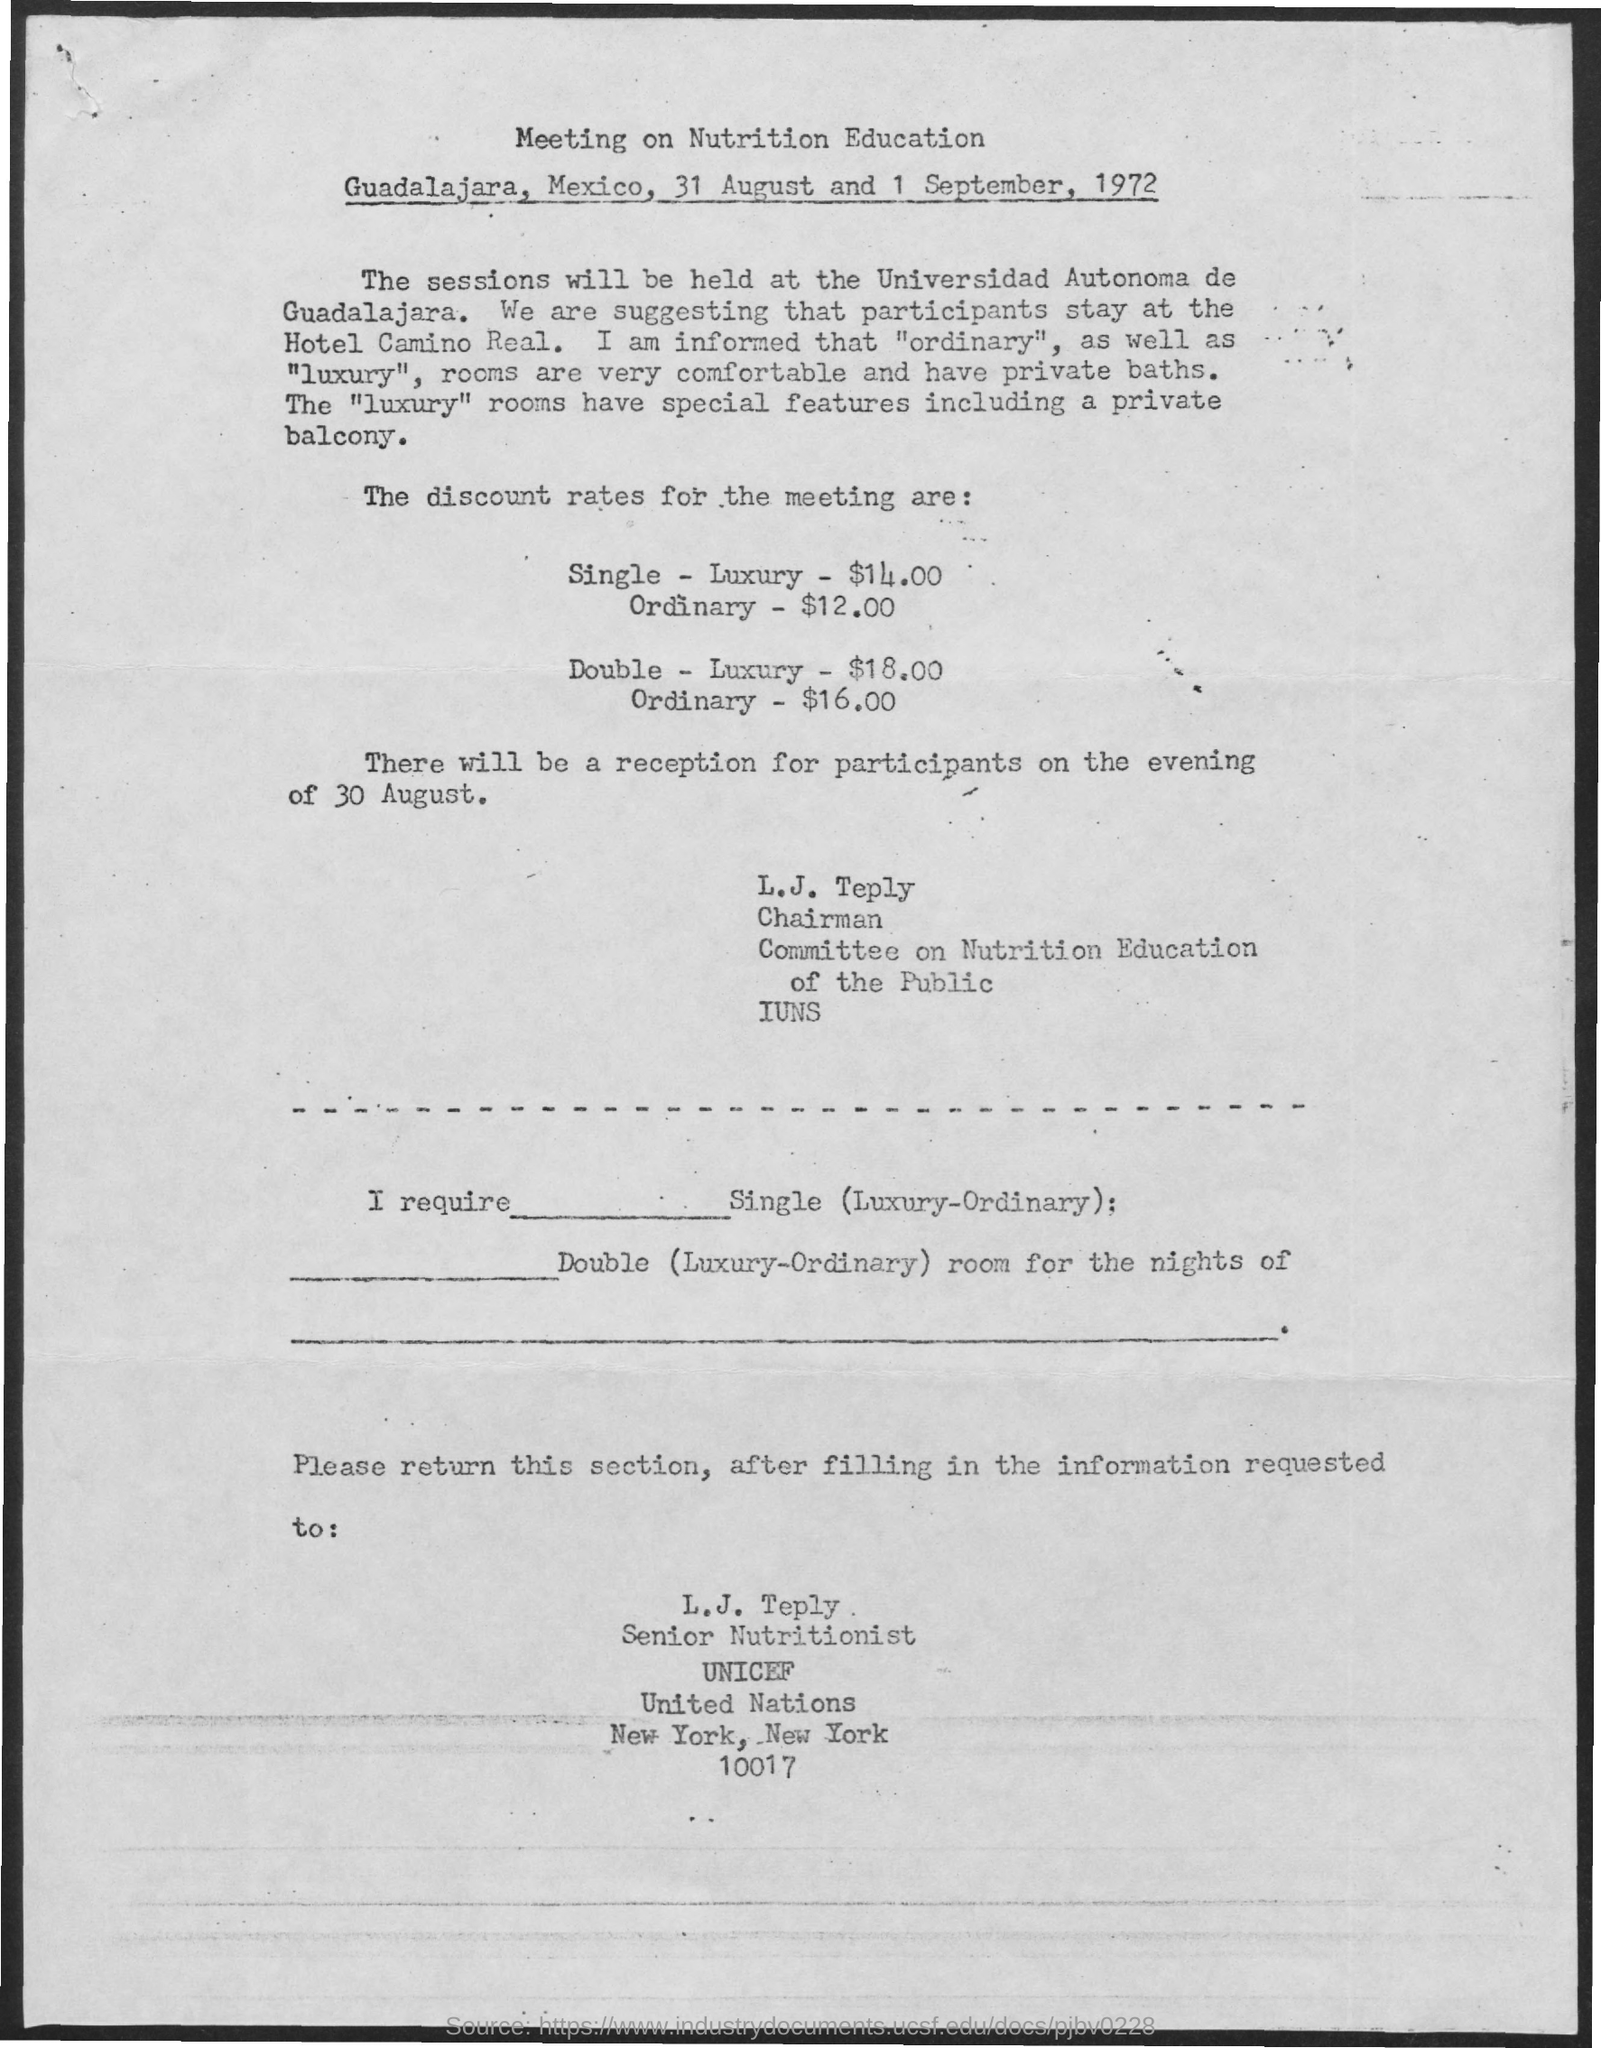Outline some significant characteristics in this image. The session will be held at the Universidad Autonoma de Guadalajara. The participants are advised to stay at the Hotel Camino Real. The discount rate for meeting the Single - Ordinary requirement is $12.00. The reception for the participants will be held on August 30th. The discount rate for a meeting room at the Single - Luxury level is $14.00. 